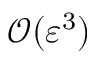<formula> <loc_0><loc_0><loc_500><loc_500>\mathcal { O } ( \varepsilon ^ { 3 } )</formula> 